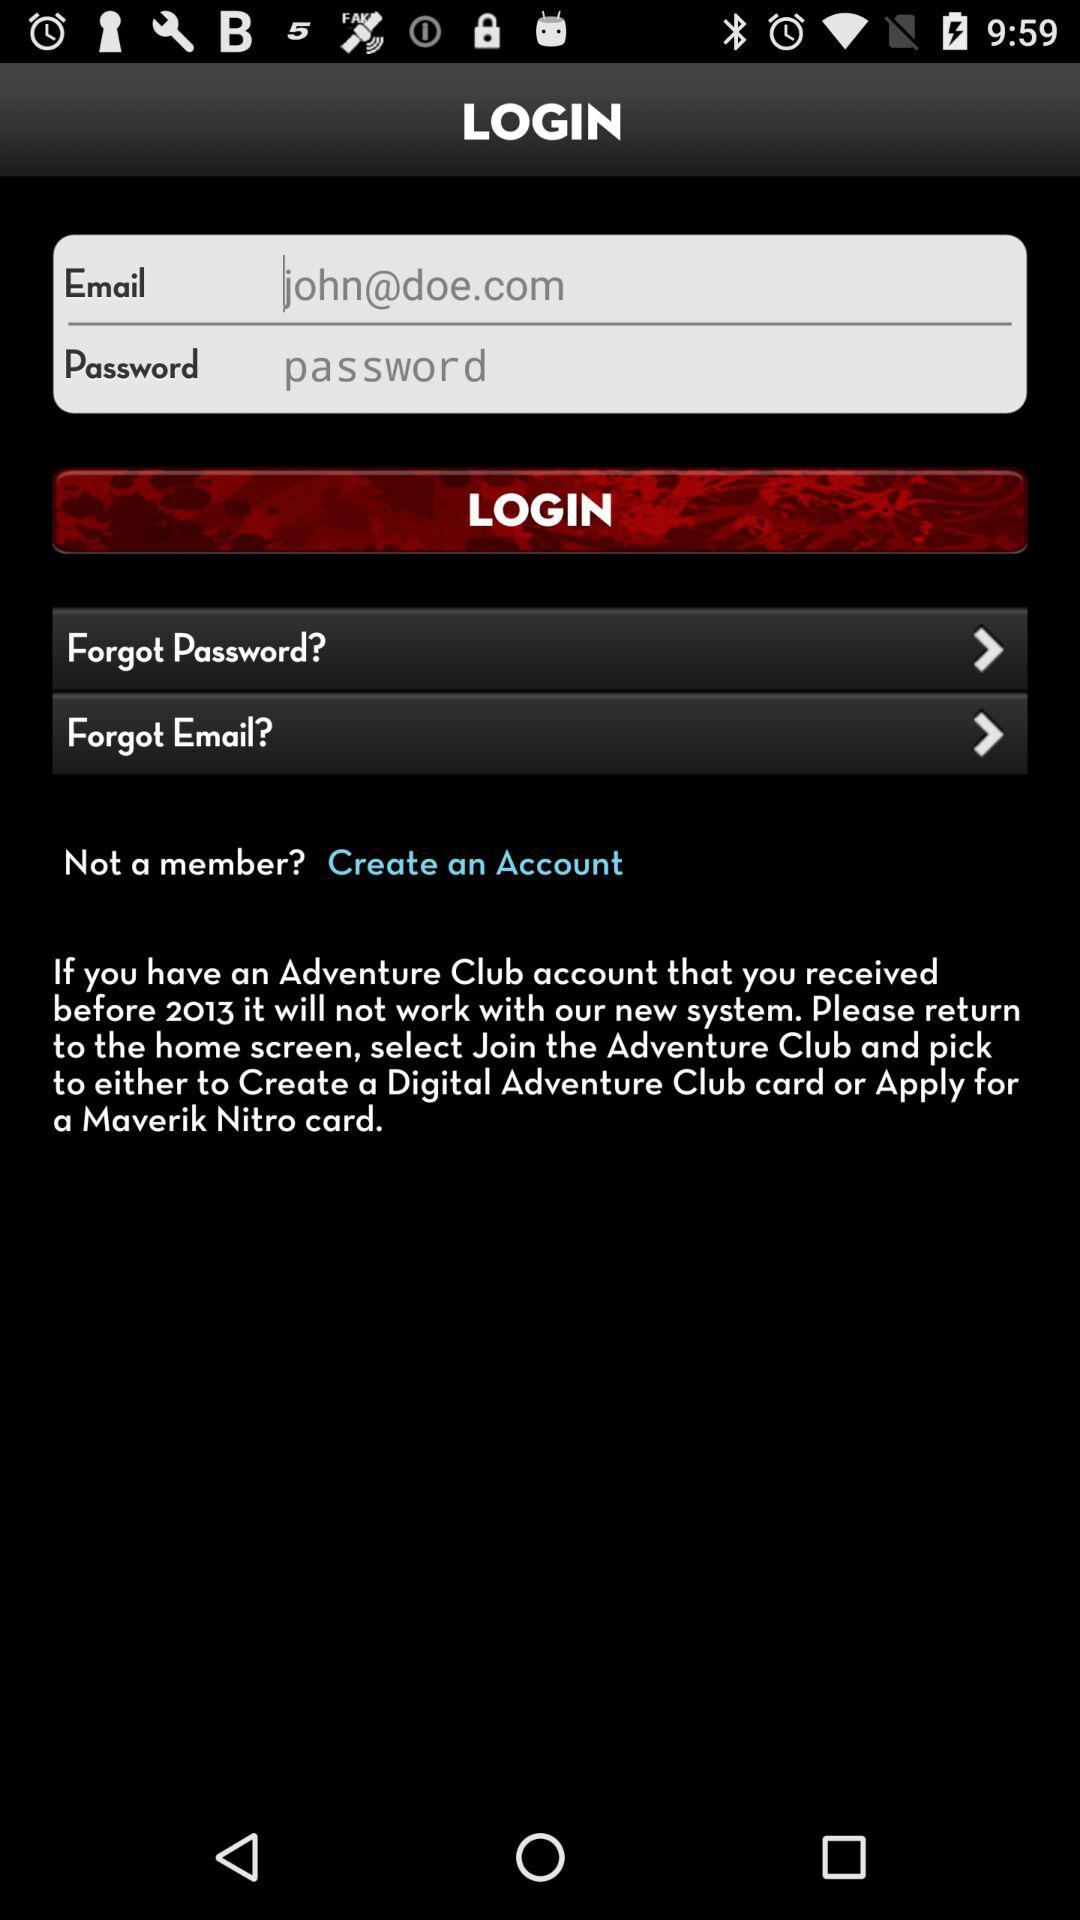What is user name?
When the provided information is insufficient, respond with <no answer>. <no answer> 